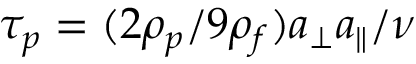<formula> <loc_0><loc_0><loc_500><loc_500>\tau _ { p } = ( { 2 \rho _ { p } } / { 9 \rho _ { f } } ) a _ { \perp } a _ { \| } / \nu</formula> 